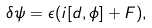Convert formula to latex. <formula><loc_0><loc_0><loc_500><loc_500>\delta \psi = \epsilon ( i [ d , \phi ] + F ) ,</formula> 